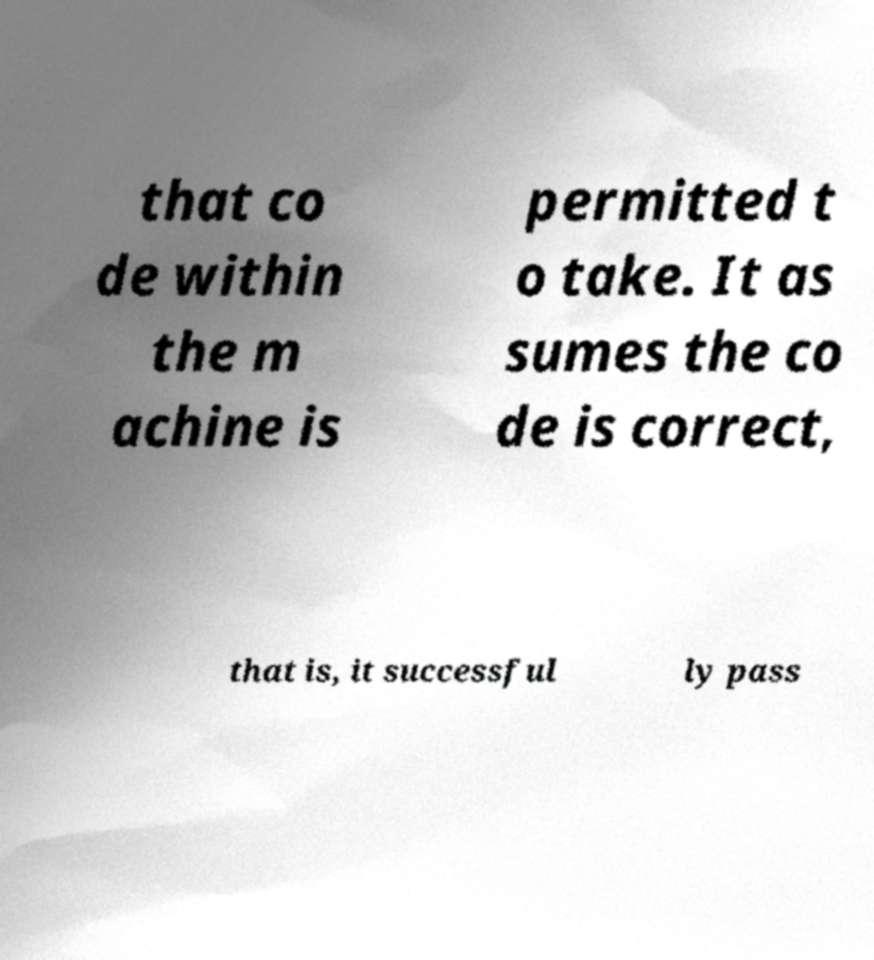For documentation purposes, I need the text within this image transcribed. Could you provide that? that co de within the m achine is permitted t o take. It as sumes the co de is correct, that is, it successful ly pass 